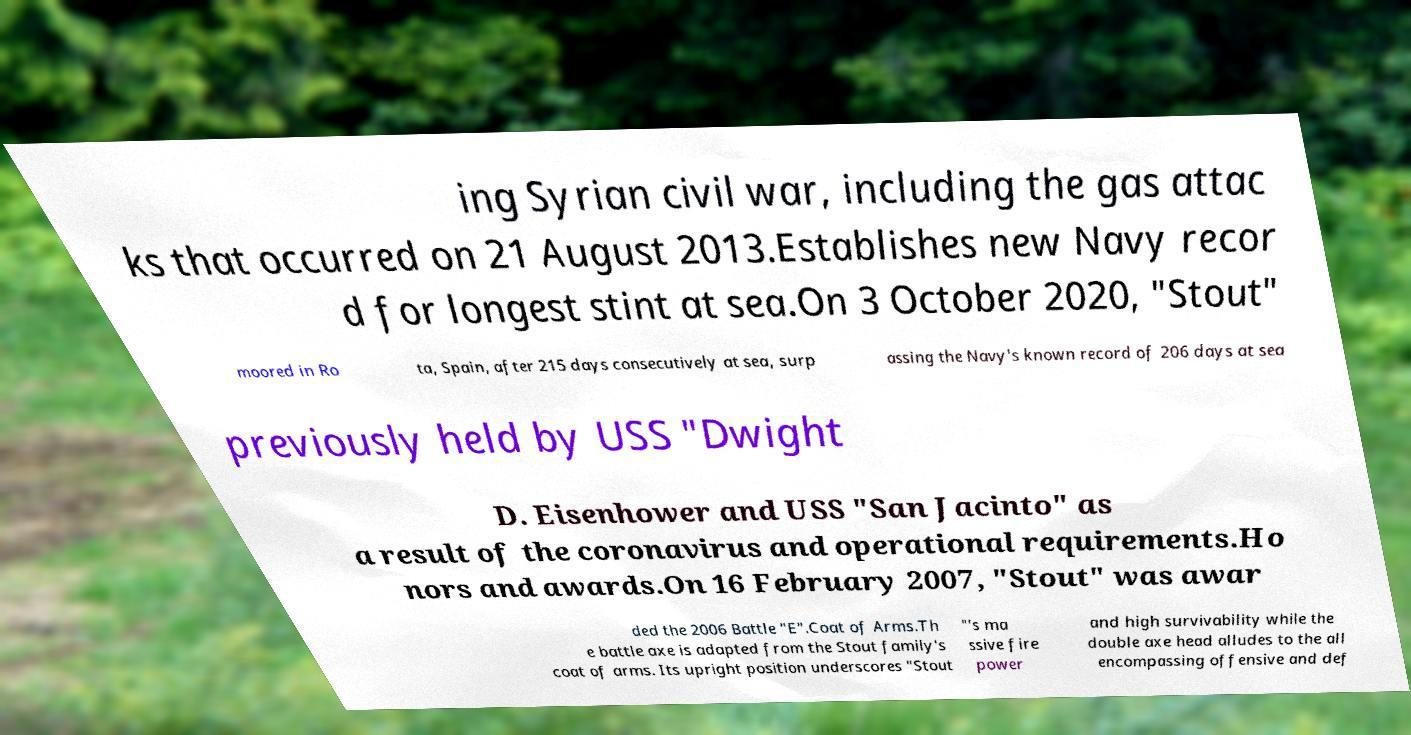I need the written content from this picture converted into text. Can you do that? ing Syrian civil war, including the gas attac ks that occurred on 21 August 2013.Establishes new Navy recor d for longest stint at sea.On 3 October 2020, "Stout" moored in Ro ta, Spain, after 215 days consecutively at sea, surp assing the Navy's known record of 206 days at sea previously held by USS "Dwight D. Eisenhower and USS "San Jacinto" as a result of the coronavirus and operational requirements.Ho nors and awards.On 16 February 2007, "Stout" was awar ded the 2006 Battle "E".Coat of Arms.Th e battle axe is adapted from the Stout family's coat of arms. Its upright position underscores "Stout "'s ma ssive fire power and high survivability while the double axe head alludes to the all encompassing offensive and def 